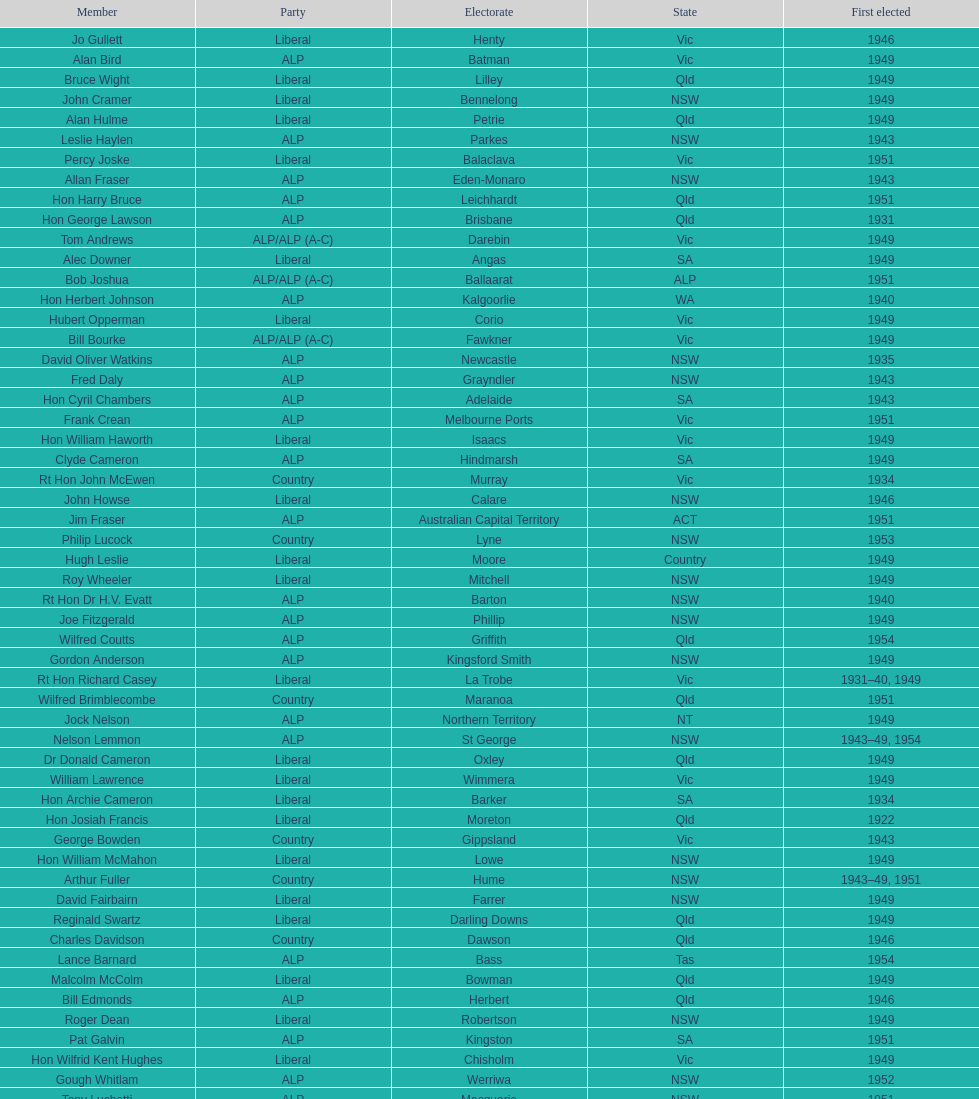Who was the first member to be elected? Charles Adermann. 